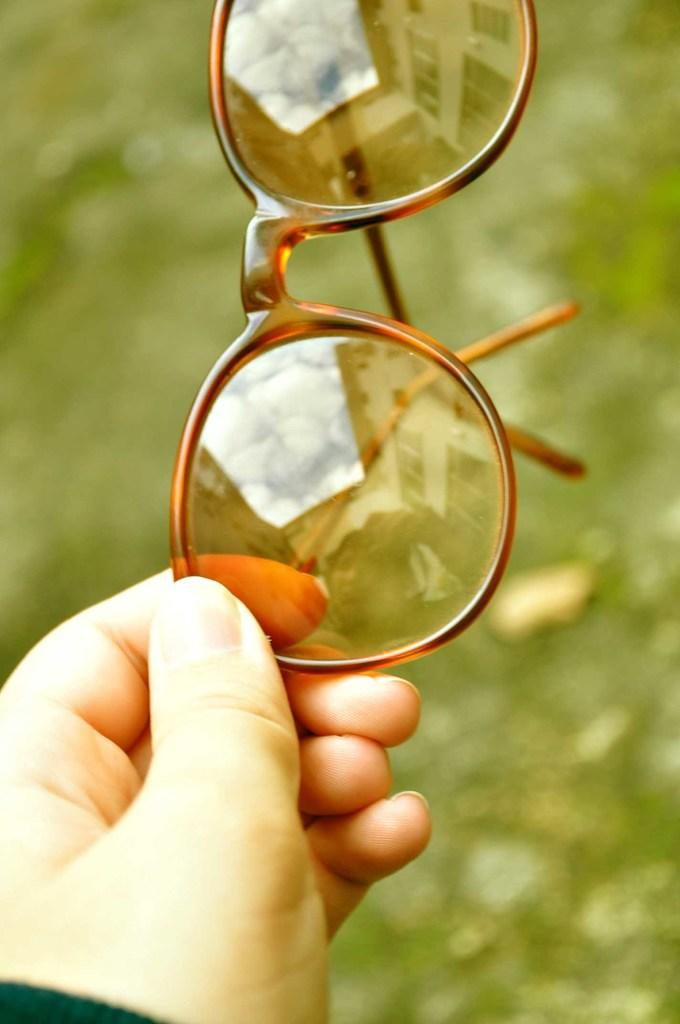What is the main subject of the image? The main subject of the image is a hand. What is the hand holding in the image? The hand is holding spectacles in the image. Can you describe the background of the image? The background of the image is blurred. What type of rifle can be seen in the hand in the image? There is no rifle present in the image; the hand is holding spectacles. Can you describe the alley in the background of the image? There is no alley present in the image; the background is blurred. 